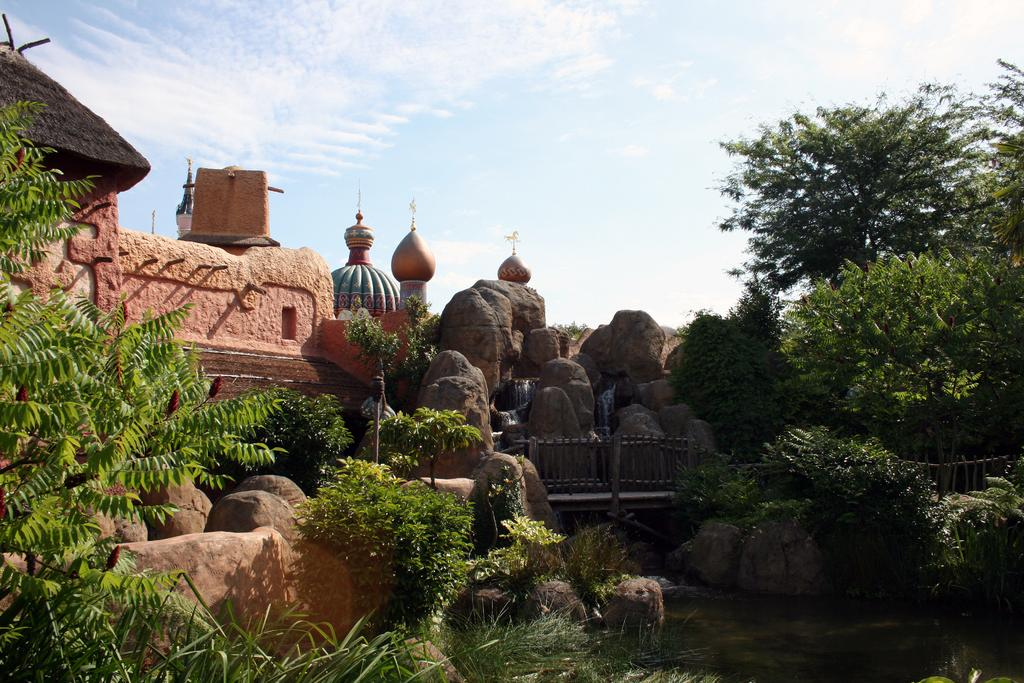What type of natural elements can be seen in the image? There are many rocks and trees in the image. What type of structure is located on the left side of the image? There is a hut on the left side of the image. What can be seen in the background of the image? There are clouds and the sky visible in the background of the image. What direction is the man walking in the image? There is no man present in the image, so it is not possible to determine the direction in which he might be walking. 